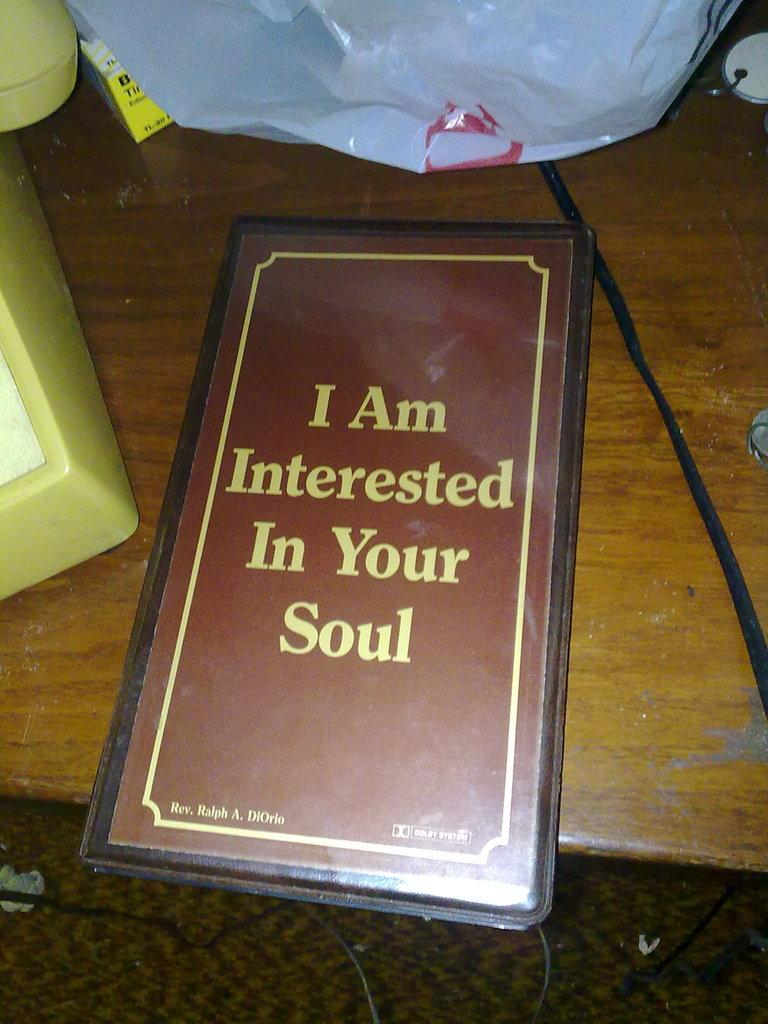<image>
Offer a succinct explanation of the picture presented. A devotional DVD on a coffee table says "I Am Interested In Your Soul." 